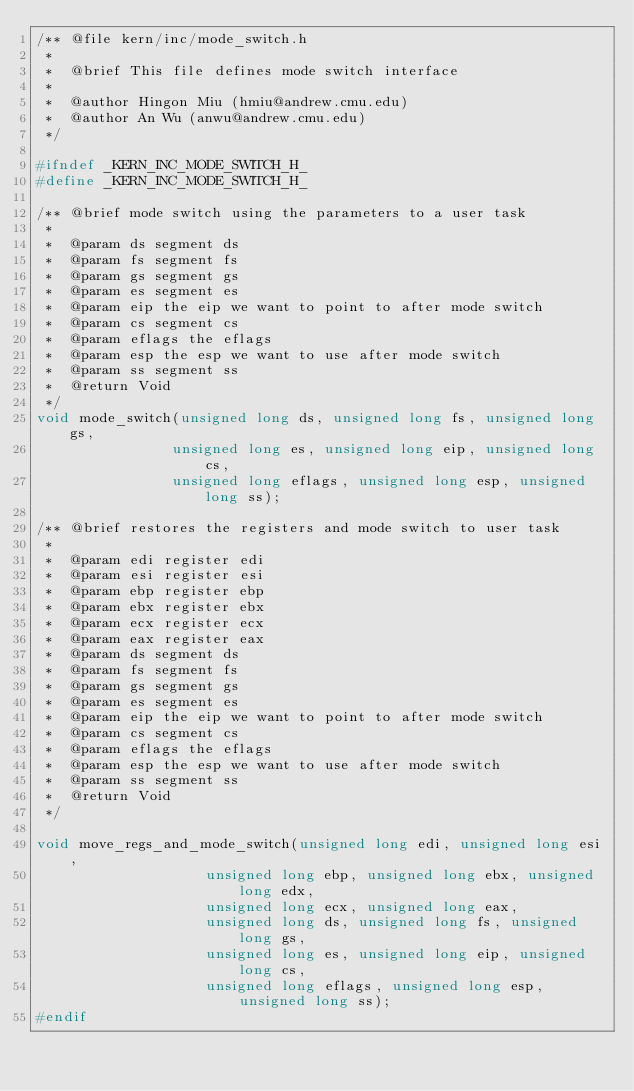Convert code to text. <code><loc_0><loc_0><loc_500><loc_500><_C_>/** @file kern/inc/mode_switch.h 
 * 
 *  @brief This file defines mode switch interface
 *
 *  @author Hingon Miu (hmiu@andrew.cmu.edu)
 *  @author An Wu (anwu@andrew.cmu.edu)
 */

#ifndef _KERN_INC_MODE_SWITCH_H_
#define _KERN_INC_MODE_SWITCH_H_

/** @brief mode switch using the parameters to a user task
 *
 *  @param ds segment ds
 *  @param fs segment fs
 *  @param gs segment gs
 *  @param es segment es
 *  @param eip the eip we want to point to after mode switch
 *  @param cs segment cs
 *  @param eflags the eflags
 *  @param esp the esp we want to use after mode switch
 *  @param ss segment ss
 *  @return Void
 */
void mode_switch(unsigned long ds, unsigned long fs, unsigned long gs,
                unsigned long es, unsigned long eip, unsigned long cs,
                unsigned long eflags, unsigned long esp, unsigned long ss);

/** @brief restores the registers and mode switch to user task
 *
 *  @param edi register edi
 *  @param esi register esi
 *  @param ebp register ebp
 *  @param ebx register ebx
 *  @param ecx register ecx
 *  @param eax register eax
 *  @param ds segment ds
 *  @param fs segment fs
 *  @param gs segment gs
 *  @param es segment es
 *  @param eip the eip we want to point to after mode switch
 *  @param cs segment cs
 *  @param eflags the eflags
 *  @param esp the esp we want to use after mode switch
 *  @param ss segment ss
 *  @return Void
 */

void move_regs_and_mode_switch(unsigned long edi, unsigned long esi, 
                    unsigned long ebp, unsigned long ebx, unsigned long edx, 
                    unsigned long ecx, unsigned long eax,
                    unsigned long ds, unsigned long fs, unsigned long gs,
                    unsigned long es, unsigned long eip, unsigned long cs,
                    unsigned long eflags, unsigned long esp, unsigned long ss);
#endif
</code> 